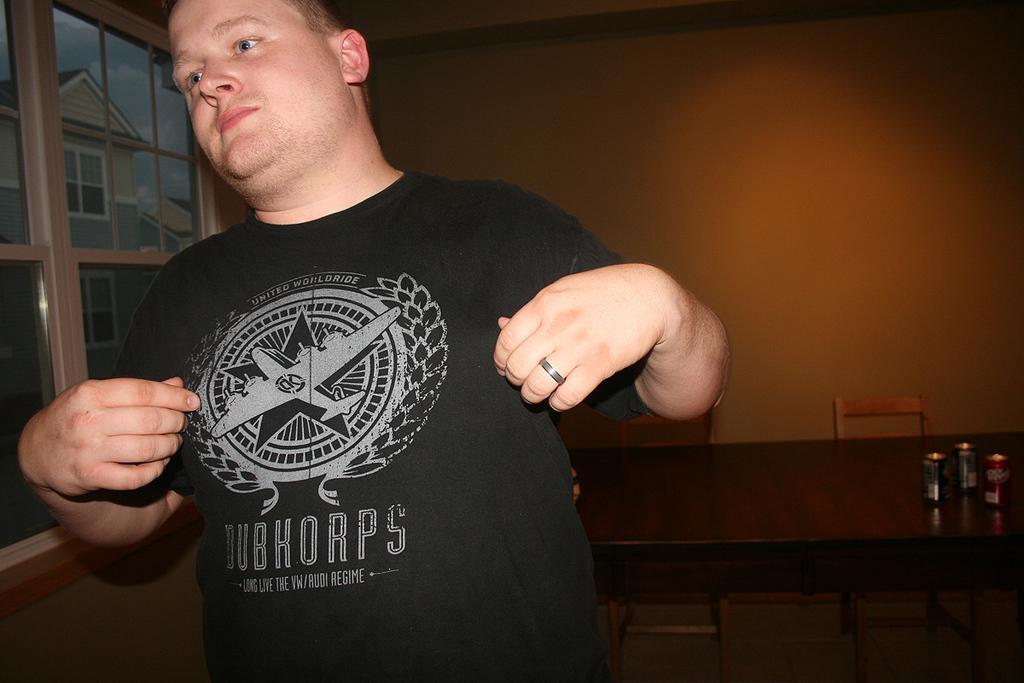Please provide a concise description of this image. The picture is taken inside a room. A man is standing wearing a black t-shirt. Beside him there is a window. Behind the man there is a table and chairs. On the table there are three cans. In the background there is a wall. 